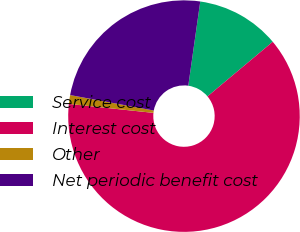Convert chart. <chart><loc_0><loc_0><loc_500><loc_500><pie_chart><fcel>Service cost<fcel>Interest cost<fcel>Other<fcel>Net periodic benefit cost<nl><fcel>11.66%<fcel>62.78%<fcel>1.23%<fcel>24.34%<nl></chart> 